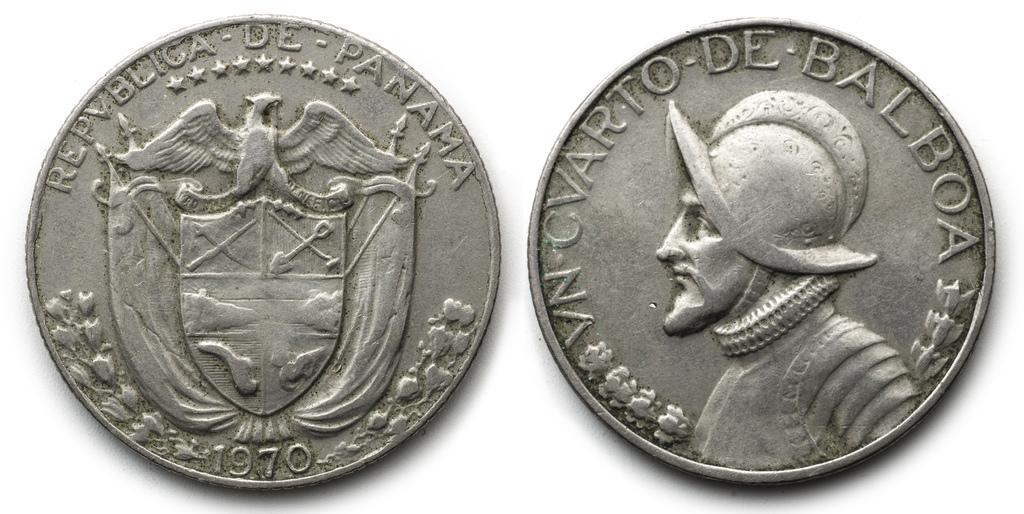<image>
Give a short and clear explanation of the subsequent image. 2 coins on a table one on heads the other on tales with the year 1970 written on it. 